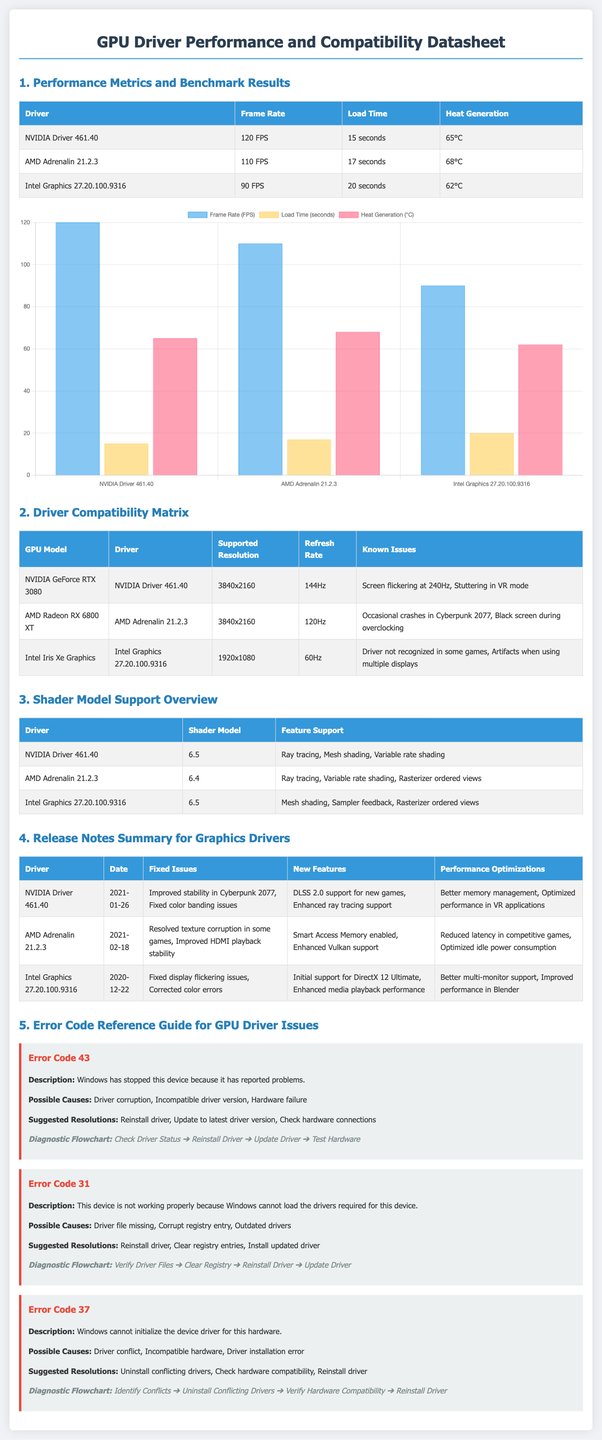What is the frame rate of NVIDIA Driver 461.40? The frame rate of NVIDIA Driver 461.40 is listed in the performance metrics section of the document.
Answer: 120 FPS What is the supported resolution for AMD Radeon RX 6800 XT? The supported resolution is provided in the Driver Compatibility Matrix section of the document.
Answer: 3840x2160 What shader model does Intel Graphics 27.20.100.9316 support? The supported shader model is mentioned in the Shader Model Support Overview section.
Answer: 6.5 What fixed issue was addressed in AMD Adrenalin 21.2.3 on February 18, 2021? The fixed issue is documented in the Release Notes Summary for Graphics Drivers section.
Answer: Resolved texture corruption in some games How many known issues are listed for Intel Iris Xe Graphics? The known issues are listed in the Driver Compatibility Matrix section and you can count them.
Answer: 2 What is the heat generation of AMD Adrenalin 21.2.3? The heat generation can be found in the Performance Metrics and Benchmark Results section.
Answer: 68°C What diagnostic flowchart is associated with Error Code 43? The flowchart is specified in the Error Code Reference Guide for GPU Driver Issues section.
Answer: Check Driver Status ➔ Reinstall Driver ➔ Update Driver ➔ Test Hardware What new feature does NVIDIA Driver 461.40 bring? The new feature is summarized in the Release Notes Summary for Graphics Drivers section of the document.
Answer: DLSS 2.0 support for new games What is the refresh rate of NVIDIA GeForce RTX 3080? The refresh rate is specified in the Driver Compatibility Matrix section.
Answer: 144Hz 